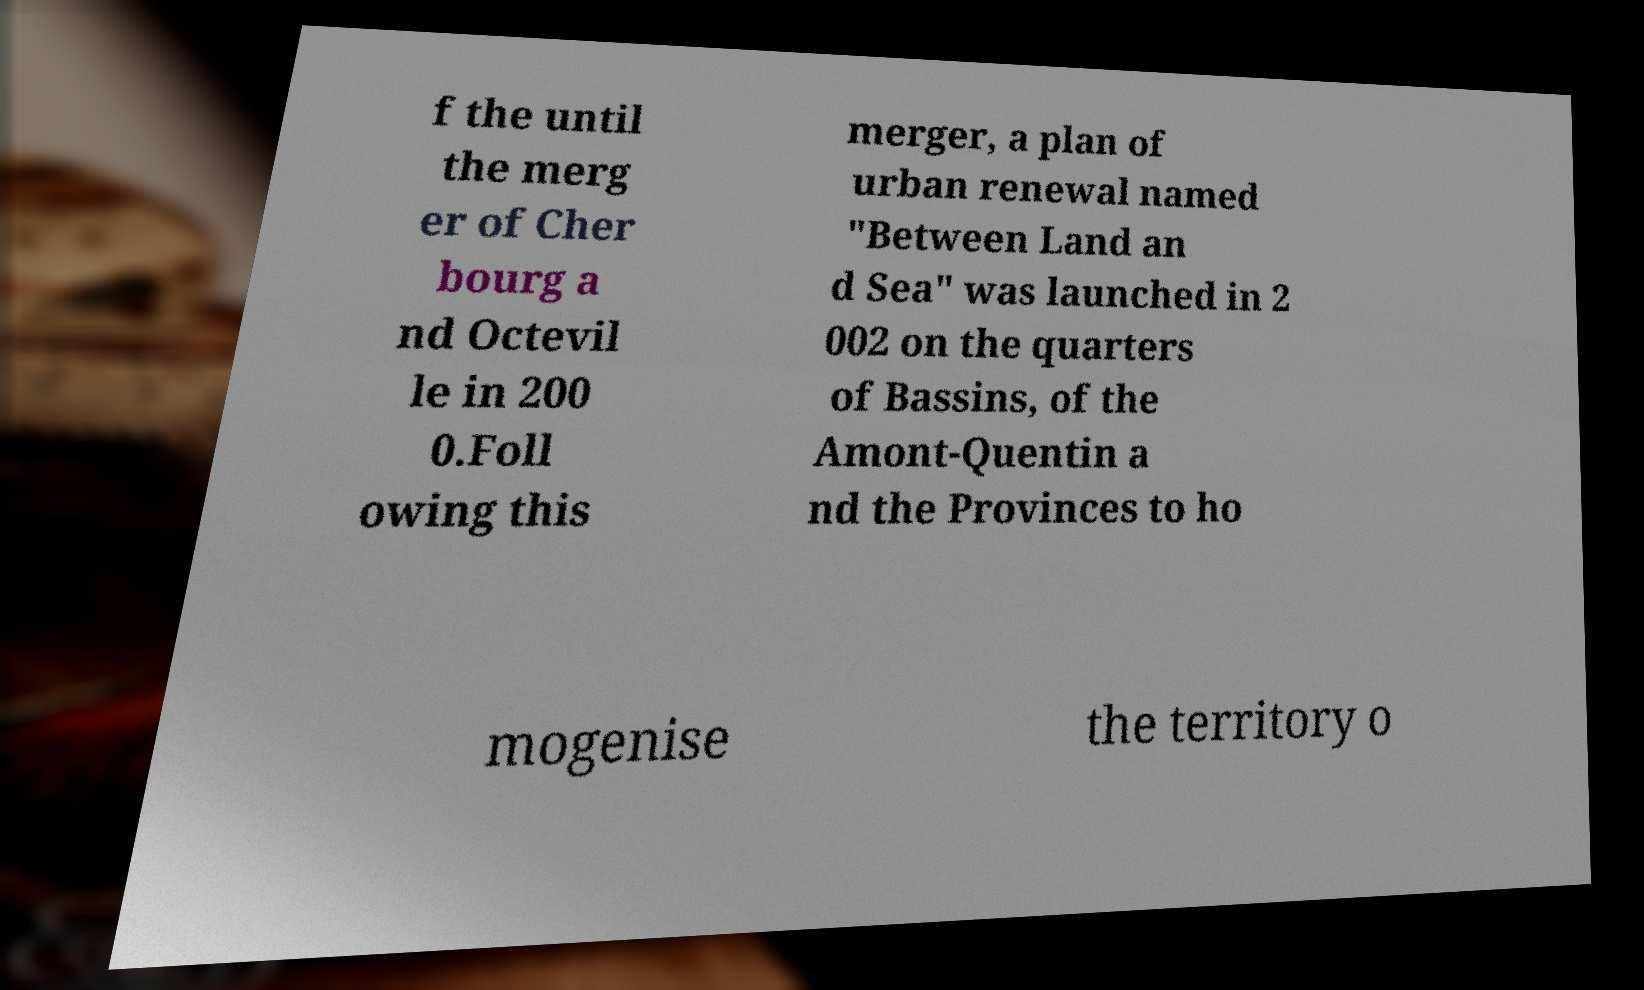There's text embedded in this image that I need extracted. Can you transcribe it verbatim? f the until the merg er of Cher bourg a nd Octevil le in 200 0.Foll owing this merger, a plan of urban renewal named "Between Land an d Sea" was launched in 2 002 on the quarters of Bassins, of the Amont-Quentin a nd the Provinces to ho mogenise the territory o 